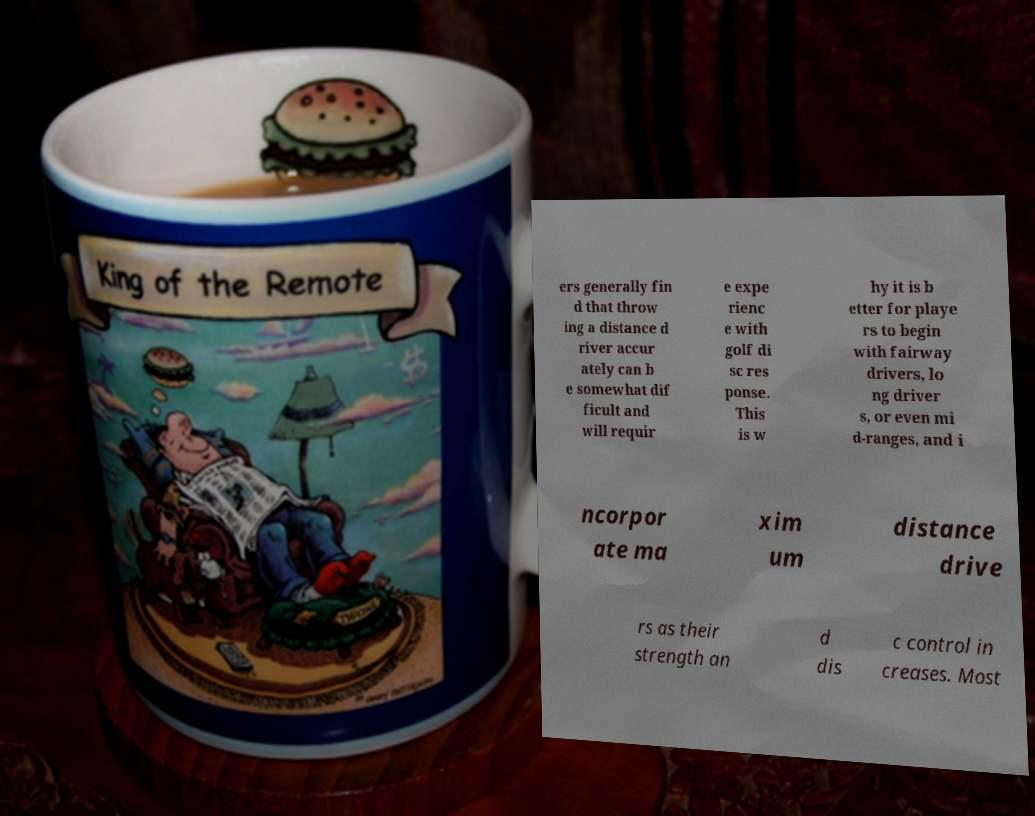There's text embedded in this image that I need extracted. Can you transcribe it verbatim? ers generally fin d that throw ing a distance d river accur ately can b e somewhat dif ficult and will requir e expe rienc e with golf di sc res ponse. This is w hy it is b etter for playe rs to begin with fairway drivers, lo ng driver s, or even mi d-ranges, and i ncorpor ate ma xim um distance drive rs as their strength an d dis c control in creases. Most 